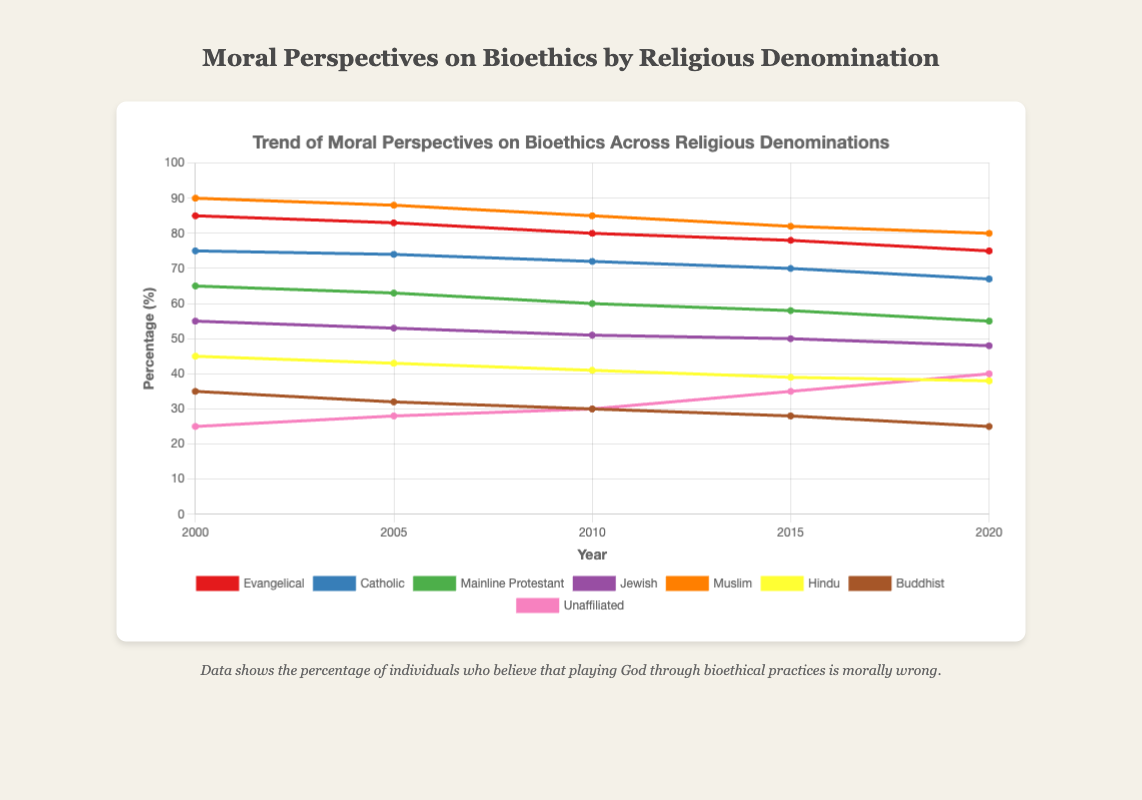What's the percentage difference in belief that playing God through bioethical practices is morally wrong between Evangelicals and Catholics in 2000? To find the difference, subtract the Catholic percentage (75) from the Evangelical percentage (85): 85 - 75 = 10
Answer: 10 Which religious group shows the highest percentage disagreement with bioethical practices in 2020? By checking the data for 2020, the Muslim group has the highest percentage at 80.
Answer: Muslim What is the trend in belief among Mainline Protestants from 2000 to 2020? Is it increasing or decreasing? From the chart, the percentages for Mainline Protestants are: 65 (2000), 63 (2005), 60 (2010), 58 (2015), and 55 (2020). This indicates a decreasing trend.
Answer: Decreasing Identify the two groups that show an increasing trend in belief that bioethical practices are morally wrong between 2000 and 2020. By observing the trends, the Unaffiliated group increases from 25 (2000) to 40 (2020), and the Buddhist group increases from 35 (2000) to 25 (2020), hence showing an increasing trend.
Answer: Unaffiliated What is the average percentage of Muslims who disagree with bioethical practices over the five data points? To find the average, sum the percentages (90 + 88 + 85 + 82 + 80) = 425 and divide by 5. The result is 425 / 5 = 85.
Answer: 85 Which group's percentage of disagreement changed the most from 2000 to 2020? Calculate the change for each group: 
Evangelical: 85 - 75 = 10, 
Catholic: 75 - 67 = 8, 
Mainline Protestant: 65 - 55 = 10, 
Jewish: 55 - 48 = 7, 
Muslim: 90 - 80 = 10, 
Hindu: 45 - 38 = 7, 
Buddhist: 35 - 25 = 10, 
Unaffiliated: 25 - 40 = -15. 
The Unaffiliated group has the biggest change of 15 (increasing from 25 to 40).
Answer: Unaffiliated Which group has had a continuous decrease in disagreement with bioethical practices over the years without any increase in between? By looking at the data, the Buddhist group's percentages are: 35 (2000), 32 (2005), 30 (2010), 28 (2015), and 25 (2020). This shows a continuous decrease.
Answer: Buddhist Compare the trend line color of the Catholic group to that of the Hindu group. The Catholic group's trend line is blue, while the Hindu group's trend line is yellow.
Answer: Blue, Yellow 